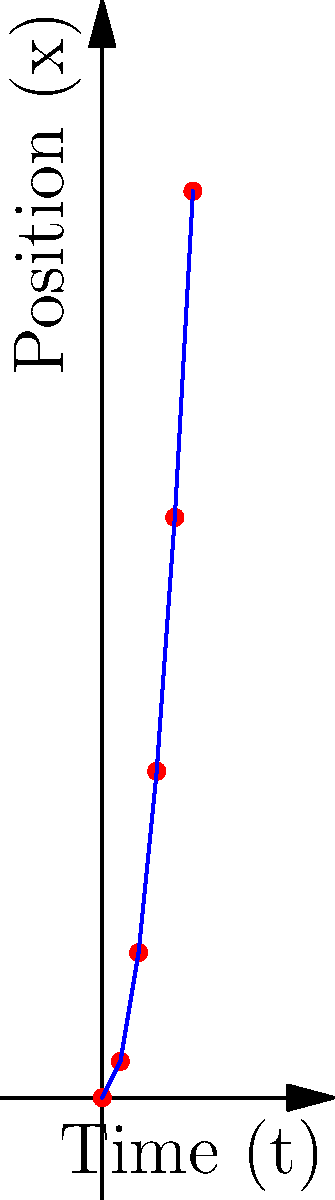Given the time series data of a spacecraft's position $(t,x)$ as shown in the graph, where $t$ is time in hours and $x$ is distance in light-years, what is the most likely equation describing the spacecraft's trajectory? Assume the spacecraft's motion can be modeled by a polynomial function. To determine the most likely equation for the spacecraft's trajectory, we'll follow these steps:

1. Observe the pattern: The graph shows a curved line, suggesting a polynomial function.

2. Analyze the degree: The curve appears to be parabolic, indicating a quadratic function (degree 2).

3. General form: A quadratic function has the form $x(t) = at^2 + bt + c$, where $a$, $b$, and $c$ are constants.

4. Use data points: We'll use $(0,0)$, $(1,2)$, and $(2,8)$ to solve for $a$, $b$, and $c$.

5. Substituting values:
   $0 = a(0)^2 + b(0) + c$
   $2 = a(1)^2 + b(1) + c$
   $8 = a(2)^2 + b(2) + c$

6. Simplifying:
   $c = 0$
   $2 = a + b$
   $8 = 4a + 2b$

7. Solving the system of equations:
   Subtracting twice the second equation from the third:
   $4 = 2a$
   $a = 2$
   
   Substituting back:
   $2 = 2 + b$
   $b = 0$

8. Final equation: $x(t) = 2t^2 + 0t + 0$, which simplifies to $x(t) = 2t^2$

9. Verification: This equation fits all given data points.

Therefore, the most likely equation describing the spacecraft's trajectory is $x(t) = 2t^2$.
Answer: $x(t) = 2t^2$ 